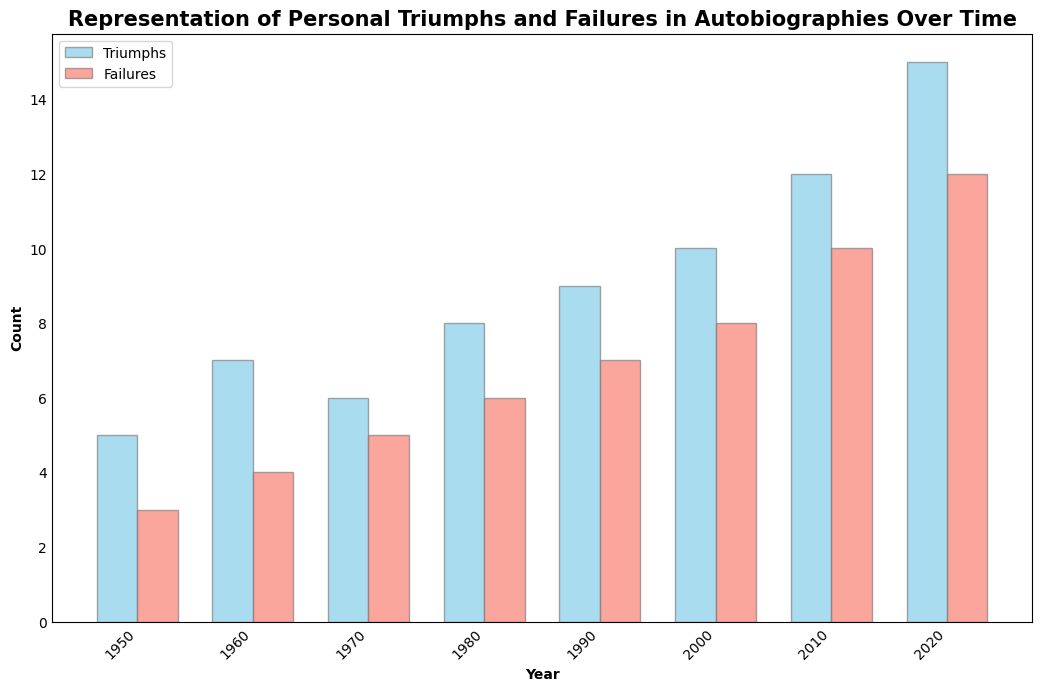Which year shows the highest number of personal triumphs? Examine the heights of the blue bars representing triumphs. The highest blue bar appears in the year 2020.
Answer: 2020 Which year had the smallest difference between the count of personal triumphs and failures? Calculate the differences for each year: 1950 = 5-3=2, 1960 = 7-4=3, 1970 = 6-5=1, 1980 = 8-6=2, 1990 = 9-7=2, 2000 = 10-8=2, 2010 = 12-10=2, 2020 = 15-12=3. Inspecting the calculations, the year with the smallest difference is 1970.
Answer: 1970 In which year are the numbers of triumphs and failures closest in value? Look at the height difference between the blue and red bars for each year. The year with the smallest height difference between the blue (triumphs) and red (failures) bars is 1970.
Answer: 1970 Overall, which category (triumphs or failures) shows a steeper increase over time? Analyze the slopes formed by connecting the tops of the blue (triumphs) and red (failures) bars. The blue bars (triumphs) exhibit a steeper increase compared to the red bars (failures).
Answer: Triumphs How many more personal triumphs are represented in 2020 compared to 1950? Identify the heights of the blue bars in 2020 (15) and 1950 (5). Subtract the values: 15 - 5 = 10.
Answer: 10 Which decade sees the first instance where the count of failures reaches double digits? Check the heights of the red bars, noting the first occurrence of values 10 or greater. This first happens in the year 2010, during the 2010s decade.
Answer: 2010s What is the total count of personal triumphs represented in the years 1950, 1960, and 1970 combined? Sum up the heights of the blue bars for the years 1950 (5), 1960 (7), and 1970 (6). Total = 5 + 7 + 6 = 18.
Answer: 18 Which year has the highest combined total of personal triumphs and failures? For each year, add the heights of the blue and red bars and compare the sums: 1950 = 5+3=8, 1960 = 7+4=11, 1970 = 6+5=11, 1980 = 8+6=14, 1990 = 9+7=16, 2000 = 10+8=18, 2010 = 12+10=22, 2020 = 15+12=27. The highest combined total is in 2020.
Answer: 2020 